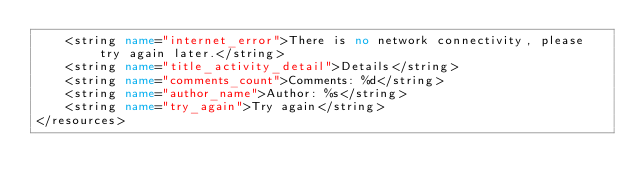<code> <loc_0><loc_0><loc_500><loc_500><_XML_>    <string name="internet_error">There is no network connectivity, please try again later.</string>
    <string name="title_activity_detail">Details</string>
    <string name="comments_count">Comments: %d</string>
    <string name="author_name">Author: %s</string>
    <string name="try_again">Try again</string>
</resources>
</code> 